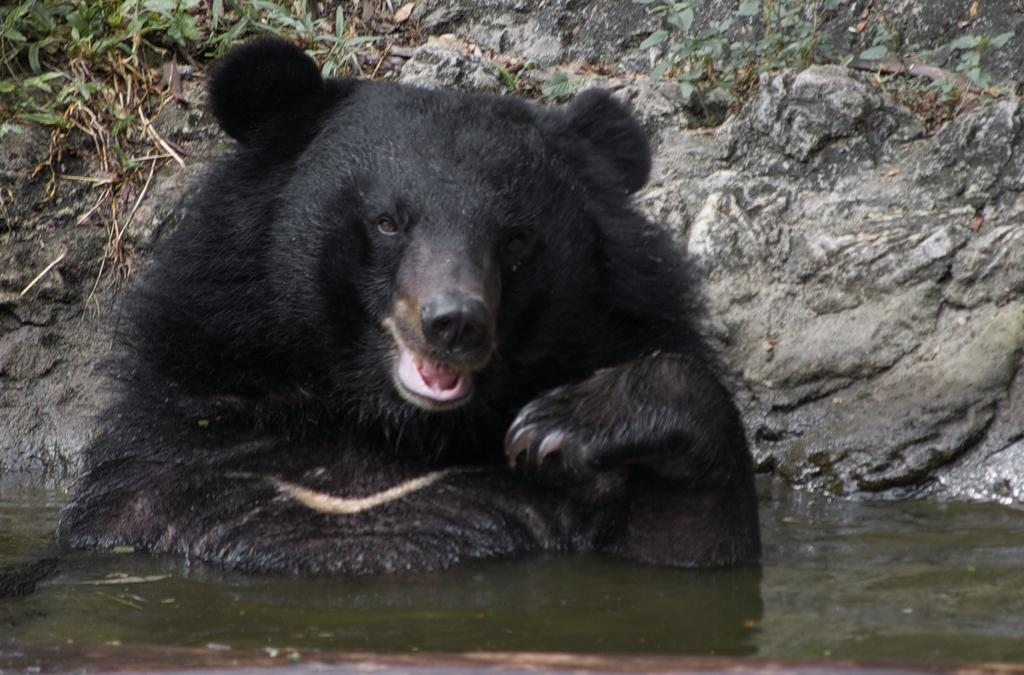What type of animal is in the image? There is a black bear in the image. Where is the black bear located in the image? The black bear is in the water. What other objects or features can be seen in the image? There is a rock and small plants present in the image. What type of bread is the black bear holding in the image? There is no bread present in the image; the black bear is in the water and not holding any bread. 